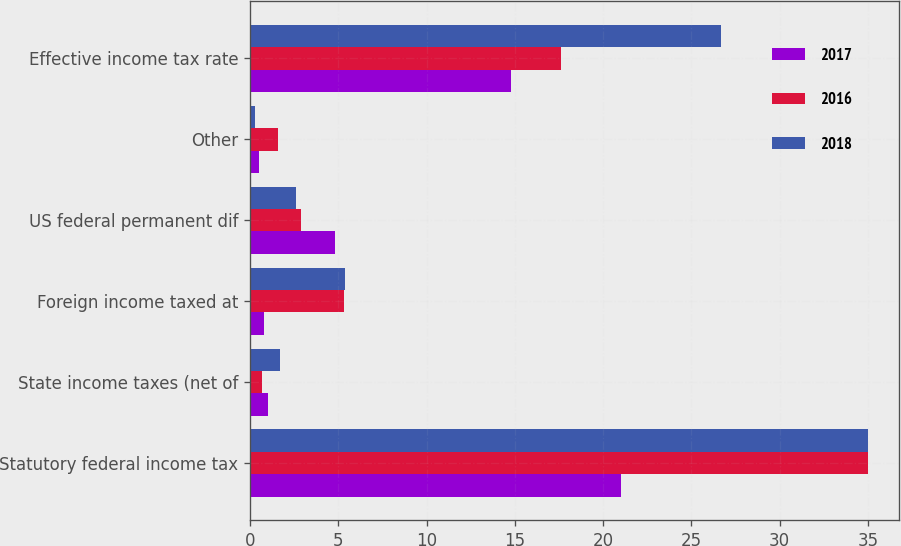Convert chart. <chart><loc_0><loc_0><loc_500><loc_500><stacked_bar_chart><ecel><fcel>Statutory federal income tax<fcel>State income taxes (net of<fcel>Foreign income taxed at<fcel>US federal permanent dif<fcel>Other<fcel>Effective income tax rate<nl><fcel>2017<fcel>21<fcel>1<fcel>0.8<fcel>4.8<fcel>0.5<fcel>14.8<nl><fcel>2016<fcel>35<fcel>0.7<fcel>5.3<fcel>2.9<fcel>1.6<fcel>17.6<nl><fcel>2018<fcel>35<fcel>1.7<fcel>5.4<fcel>2.6<fcel>0.3<fcel>26.7<nl></chart> 